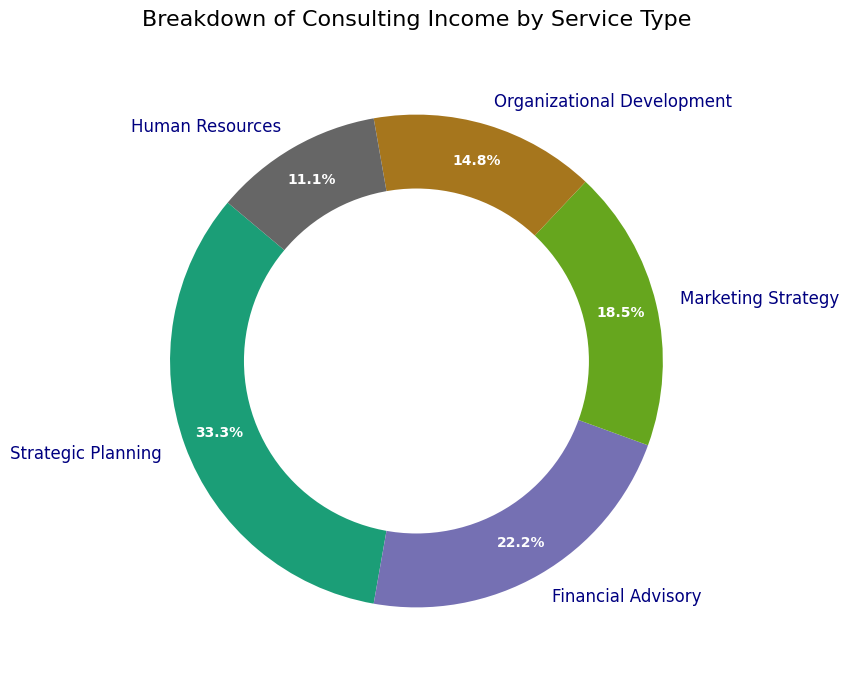What is the percentage of consulting income derived from Financial Advisory services? Look at the pie chart and find the slice labeled "Financial Advisory." It is marked with a percentage, which indicates the proportion of total income this service type represents.
Answer: 24.0% Which service type contributes the most to the overall consulting income? Identify the largest slice in the pie chart. The slice with the highest percentage represents the service type contributing the most.
Answer: Strategic Planning How much more income is generated from Marketing Strategy compared to Human Resources? Locate the slices for "Marketing Strategy" and "Human Resources," and note their respective incomes ($25,000 and $15,000). Subtract the Human Resources income from the Marketing Strategy income.
Answer: $10,000 If you combined the income from Organizational Development and Human Resources, what percentage of the total would that be? Sum the incomes from "Organizational Development" and "Human Resources" ($20,000 + $15,000). Then, calculate the percentage: (Total combined income / Total consulting income) * 100.
Answer: 22.2% Which service type is represented by the darkest color in the pie chart? Visually inspect the pie chart and identify the slice with the darkest color.
Answer: Strategic Planning Is the income from Strategic Planning greater than the combined income from Financial Advisory and Organizational Development? Compare the income from "Strategic Planning" ($45,000) with the combined income from "Financial Advisory" and "Organizational Development" ($30,000 + $20,000 = $50,000).
Answer: No How does the size of the slice for Marketing Strategy compare to the slice for Organizational Development? Visually compare the sizes of the slices for "Marketing Strategy" and "Organizational Development." Identify if one appears larger.
Answer: Marketing Strategy is larger If you had to rank the service types by income, which would be third on the list? First, list the service types in order of their income amounts: Strategic Planning, Financial Advisory, Marketing Strategy, Organizational Development, Human Resources. The third on the list is "Marketing Strategy."
Answer: Marketing Strategy What is the difference in percentage points between the largest and smallest service type incomes? Identify the percentages of the largest and smallest slices. Subtract the smallest percentage from the largest percentage: Strategic Planning (36.0%) - Human Resources (12.0%).
Answer: 24.0 percentage points 